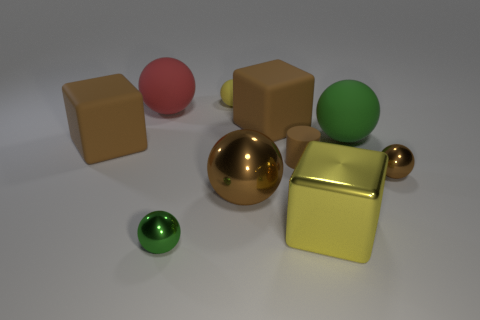How many objects are green rubber spheres or brown metallic balls?
Provide a short and direct response. 3. There is a rubber cube that is to the left of the large red thing; what is its size?
Provide a short and direct response. Large. What number of other objects are the same material as the large yellow thing?
Your response must be concise. 3. There is a big matte block that is to the left of the yellow rubber sphere; are there any big brown shiny things that are right of it?
Your answer should be compact. Yes. Is there any other thing that is the same shape as the tiny brown matte object?
Your answer should be very brief. No. What is the color of the other big rubber object that is the same shape as the big red thing?
Offer a terse response. Green. How big is the yellow sphere?
Ensure brevity in your answer.  Small. Are there fewer tiny shiny things on the left side of the red object than small balls?
Give a very brief answer. Yes. Are the large green object and the big ball that is in front of the small brown rubber object made of the same material?
Provide a short and direct response. No. Is there a brown sphere behind the brown ball left of the shiny sphere that is on the right side of the tiny brown matte object?
Your answer should be very brief. Yes. 